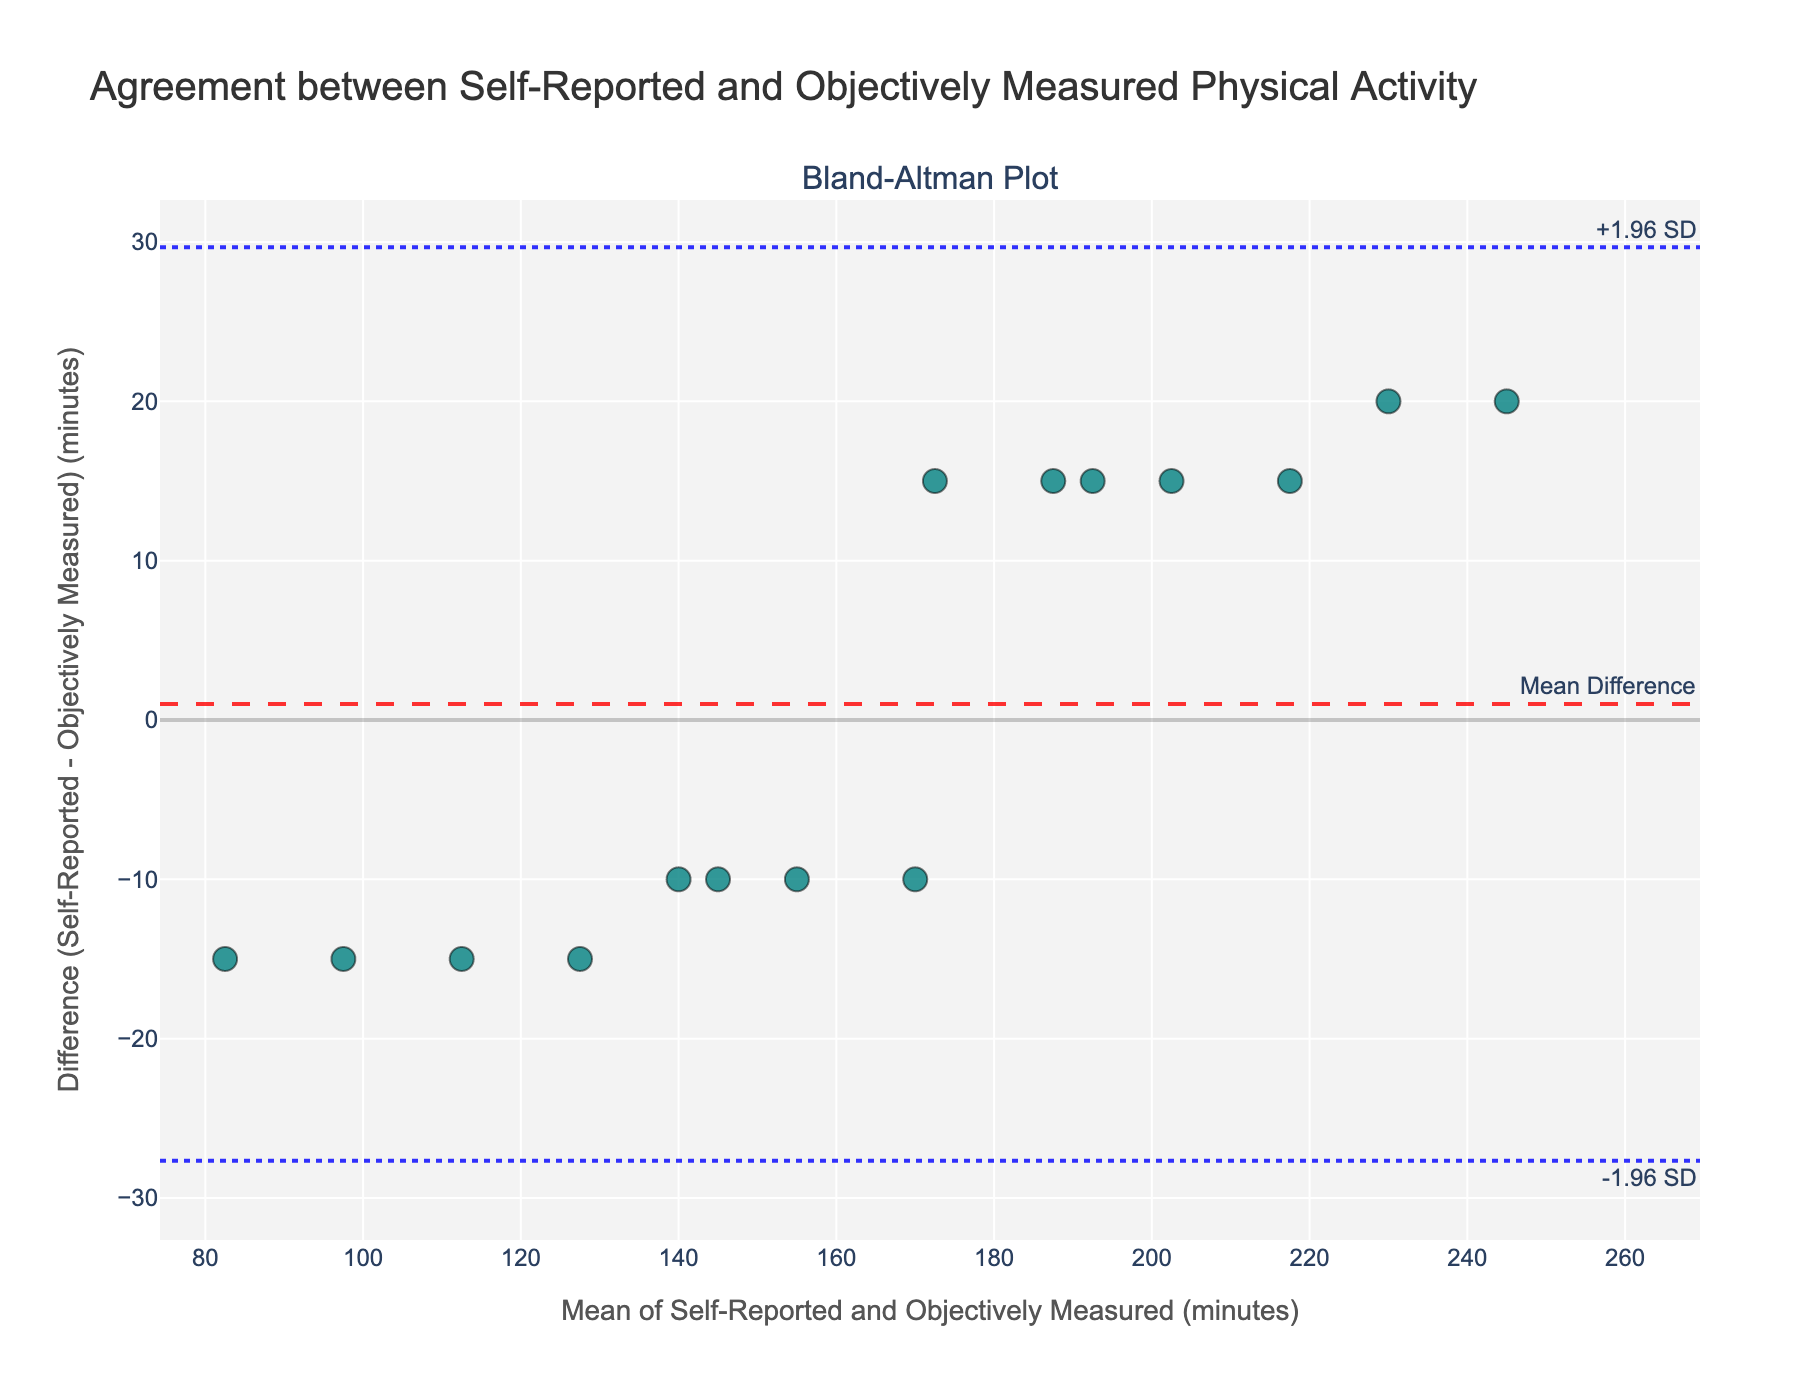How many data points are plotted on the Bland-Altman plot? To find the number of data points, count the number of markers on the plot. Each marker represents a participant's data.
Answer: 15 What is the title of the plot? The title of the plot is generally shown at the top of the figure. Read the text to identify it.
Answer: Agreement between Self-Reported and Objectively Measured Physical Activity What do the dashed and dotted lines represent in the plot? In a Bland-Altman plot, the dashed line represents the mean difference, while the dotted lines represent the limits of agreement, usually +1.96 SD and -1.96 SD from the mean difference.
Answer: Mean Difference and Limits of Agreement What is the range for the x-axis? The range for the x-axis can be observed by looking at the minimum and maximum values along the x-axis.
Answer: Approximately 67.5 to 280.5 minutes Which participant has the highest mean physical activity? To find the participant with the highest mean, calculate the mean of self-reported and objectively measured physical activity for each participant and identify the highest one. Dr. Sophia Kim has the highest mean = (255 + 235) / 2 = 245 minutes.
Answer: Dr. Sophia Kim What is the mean difference (bias) in the Bland-Altman plot? The mean difference (bias) is represented by the dashed line on the plot, annotated as "Mean Difference".
Answer: Around 3.67 minutes Are most data points within the limits of agreement? Count the number of data points that fall between the upper and lower limits of agreement. Most data points should lie within these boundaries.
Answer: Yes Which participant shows the largest discrepancy between self-reported and measured physical activity? The largest discrepancy is indicated by the point farthest from the mean difference line. Calculate the differences for each participant and find the maximum. Dr. Sophia Kim has a difference of 20 minutes.
Answer: Dr. Sophia Kim What are the colors used for data points and lines in the plot? The data points are usually of one color, while the mean difference and limits of agreement lines are in others. Observe the plot to identify these colors. The data points are teal, the mean difference line is red, and the limits of agreement are blue.
Answer: Teal, Red, and Blue What does it imply if a data point is close to the mean difference line? If a data point is close to the mean difference line, it means that the self-reported activity is very close to the objectively measured activity, indicating good agreement for that participant.
Answer: Good Agreement 